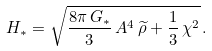<formula> <loc_0><loc_0><loc_500><loc_500>H _ { * } = \sqrt { \frac { 8 \pi \, G _ { * } } { 3 } \, A ^ { 4 } \, \widetilde { \rho } + \frac { 1 } { 3 } \, \chi ^ { 2 } } \, .</formula> 